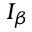Convert formula to latex. <formula><loc_0><loc_0><loc_500><loc_500>I _ { \beta }</formula> 